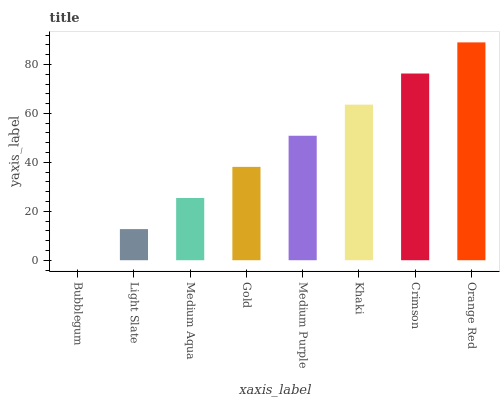Is Light Slate the minimum?
Answer yes or no. No. Is Light Slate the maximum?
Answer yes or no. No. Is Light Slate greater than Bubblegum?
Answer yes or no. Yes. Is Bubblegum less than Light Slate?
Answer yes or no. Yes. Is Bubblegum greater than Light Slate?
Answer yes or no. No. Is Light Slate less than Bubblegum?
Answer yes or no. No. Is Medium Purple the high median?
Answer yes or no. Yes. Is Gold the low median?
Answer yes or no. Yes. Is Light Slate the high median?
Answer yes or no. No. Is Bubblegum the low median?
Answer yes or no. No. 